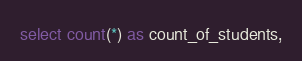Convert code to text. <code><loc_0><loc_0><loc_500><loc_500><_SQL_>select count(*) as count_of_students,</code> 